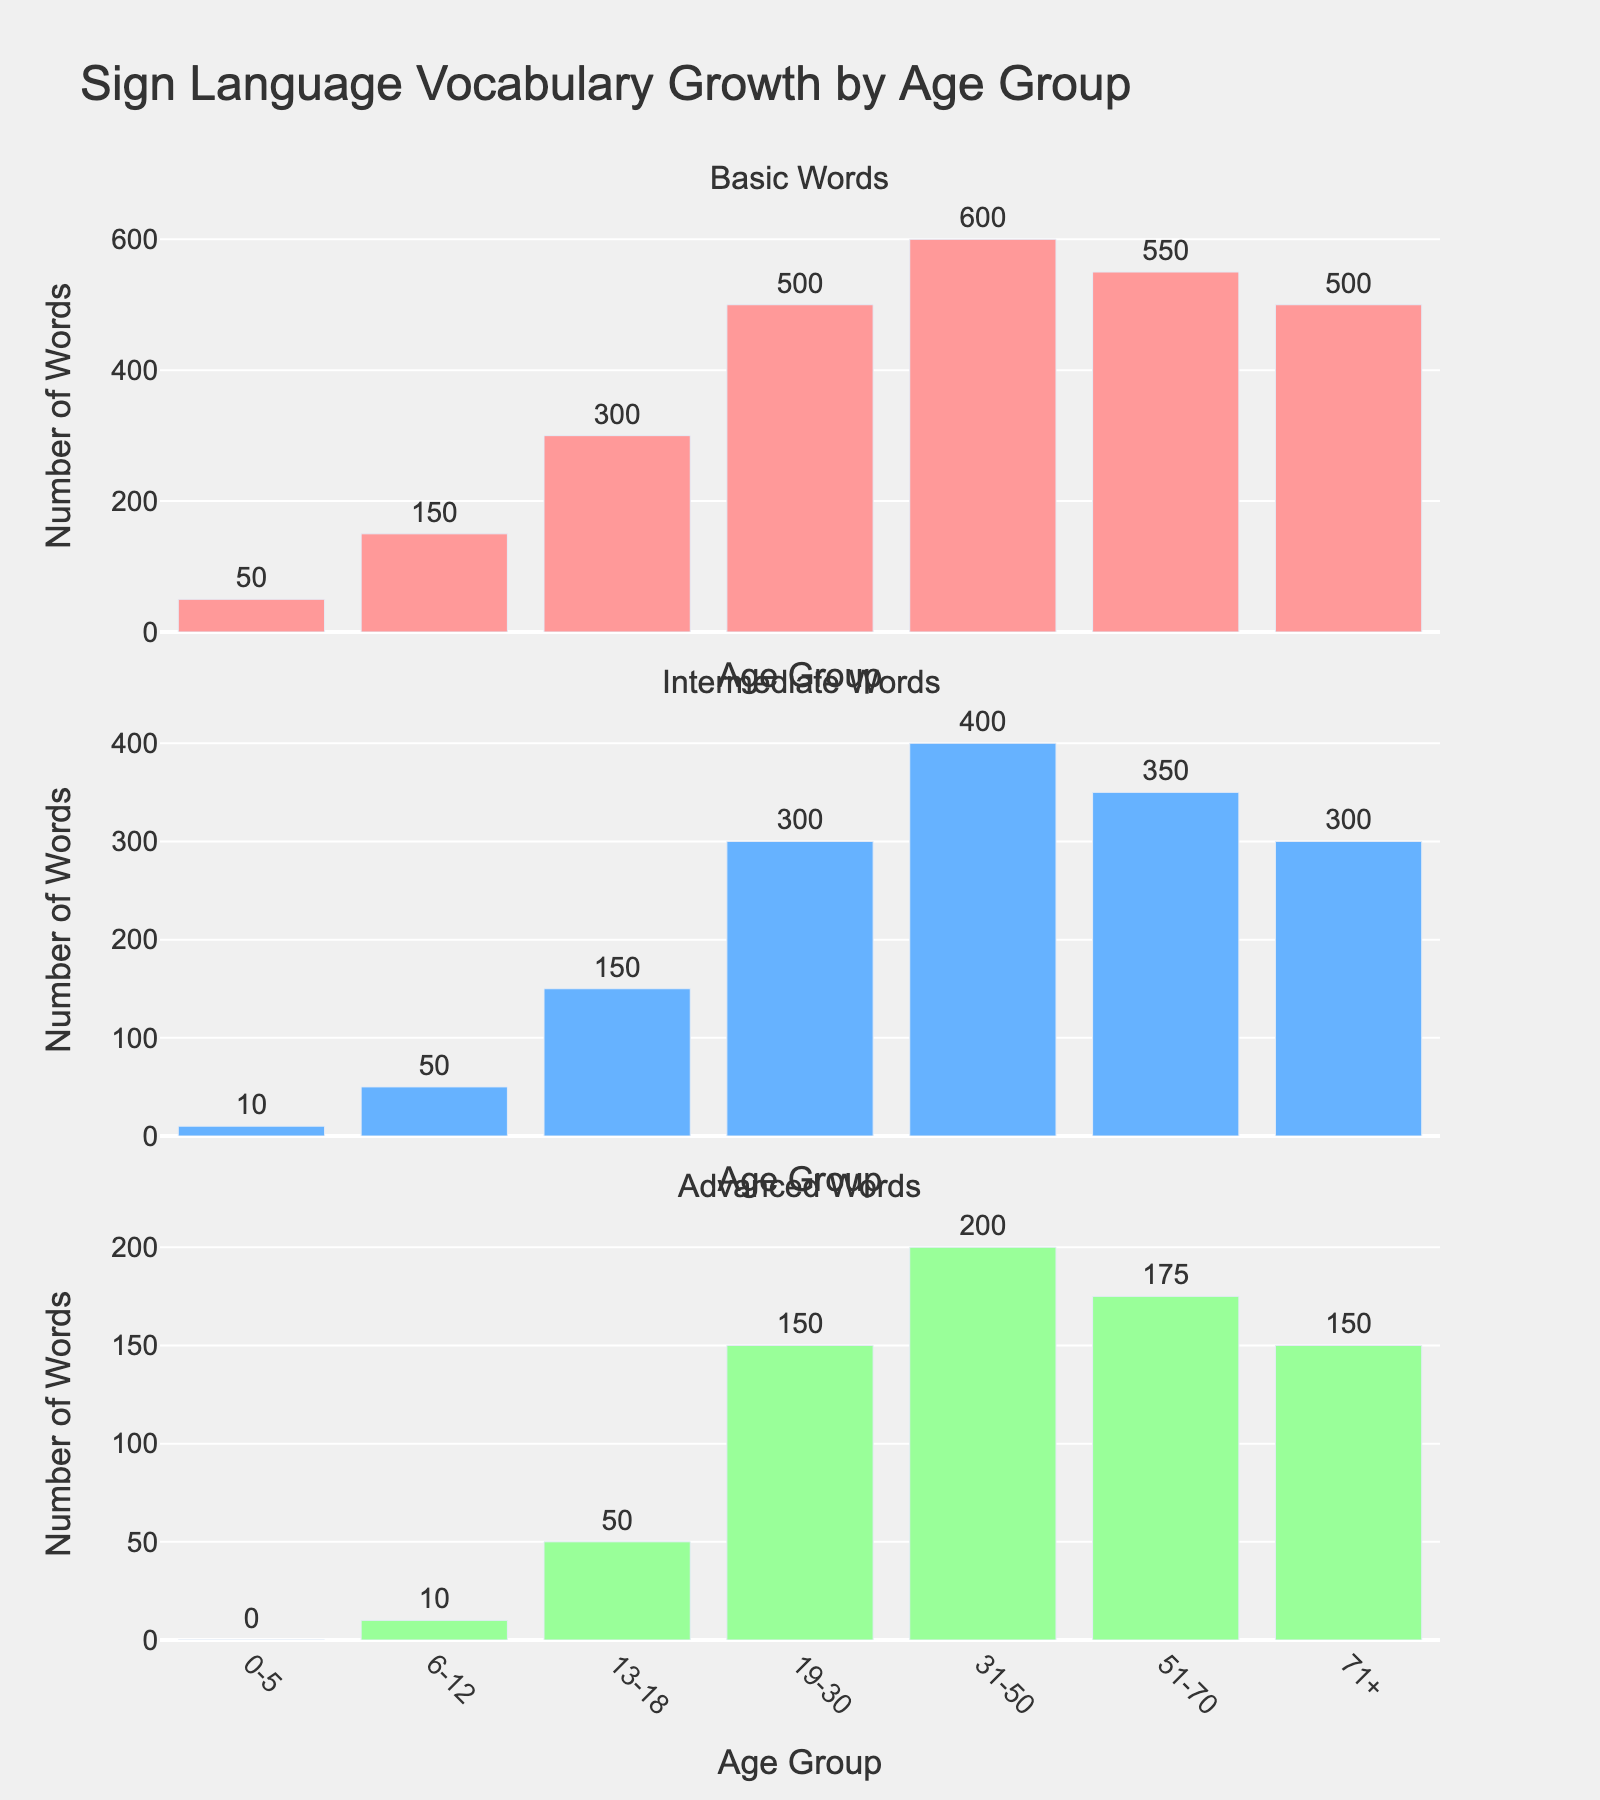What's the title of the figure? The title of the figure is generally located at the top and is clearly displayed in a larger font size. It usually provides a summary of what the figure is about.
Answer: Sign Language Vocabulary Growth by Age Group How many age groups are presented in the figure? By carefully looking at the x-axis labels of each subplot, one can add up the number of unique age groups displayed.
Answer: 7 Which age group has the highest number of Intermediate Words? By examining the heights of the bars in the Intermediate Words subplot, one can determine which bar reaches the highest point.
Answer: 31-50 What is the difference in the number of Basic Words between the age groups 31-50 and 0-5? Subtract the number of Basic Words in the 0-5 age group from the 31-50 age group by looking at the heights/numbers of the corresponding bars in the Basic Words subplot.
Answer: 550 In which age groups do the numbers of Advanced Words remain the same? By comparing the heights of the bars in the Advanced Words subplot, one can identify any age groups with equal bar heights.
Answer: 19-30 and 71+ Which age group shows a decline in the number of Basic Words compared to the previous age group? Check for any bars in the Basic Words subplot that are shorter compared to the bar immediately before them and identify the corresponding age group.
Answer: 51-70 What's the total number of Basic Words in the age groups 0-5 and 6-12? Add the values for the Basic Words in the age groups 0-5 and 6-12 by summing the heights/numbers of the corresponding bars in the Basic Words subplot.
Answer: 200 Compare the number of Advanced Words in the age group 13-18 to that in the 71+ age group. Look at the heights/numbers of the bars for the age groups 13-18 and 71+ in the Advanced Words subplot and determine if they are equal or different.
Answer: Equal 